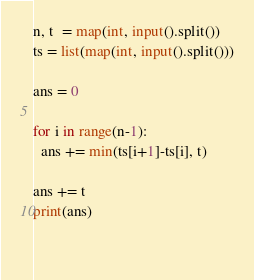Convert code to text. <code><loc_0><loc_0><loc_500><loc_500><_Python_>n, t  = map(int, input().split())
ts = list(map(int, input().split()))

ans = 0

for i in range(n-1):
  ans += min(ts[i+1]-ts[i], t)

ans += t
print(ans)
  
  </code> 